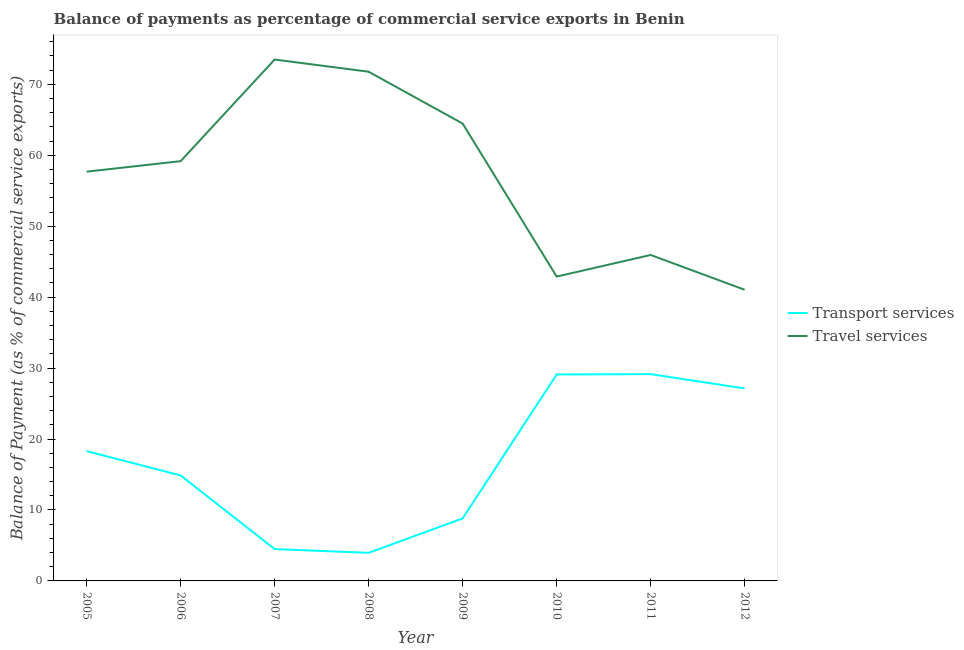What is the balance of payments of transport services in 2007?
Ensure brevity in your answer.  4.49. Across all years, what is the maximum balance of payments of travel services?
Make the answer very short. 73.49. Across all years, what is the minimum balance of payments of transport services?
Provide a short and direct response. 3.96. In which year was the balance of payments of travel services maximum?
Provide a short and direct response. 2007. In which year was the balance of payments of travel services minimum?
Ensure brevity in your answer.  2012. What is the total balance of payments of transport services in the graph?
Offer a very short reply. 135.81. What is the difference between the balance of payments of travel services in 2005 and that in 2011?
Keep it short and to the point. 11.75. What is the difference between the balance of payments of transport services in 2007 and the balance of payments of travel services in 2005?
Offer a very short reply. -53.2. What is the average balance of payments of transport services per year?
Provide a succinct answer. 16.98. In the year 2006, what is the difference between the balance of payments of travel services and balance of payments of transport services?
Keep it short and to the point. 44.29. What is the ratio of the balance of payments of travel services in 2006 to that in 2010?
Provide a short and direct response. 1.38. Is the difference between the balance of payments of travel services in 2007 and 2009 greater than the difference between the balance of payments of transport services in 2007 and 2009?
Provide a succinct answer. Yes. What is the difference between the highest and the second highest balance of payments of transport services?
Provide a short and direct response. 0.05. What is the difference between the highest and the lowest balance of payments of transport services?
Your response must be concise. 25.19. Does the balance of payments of travel services monotonically increase over the years?
Offer a terse response. No. Is the balance of payments of travel services strictly less than the balance of payments of transport services over the years?
Give a very brief answer. No. What is the difference between two consecutive major ticks on the Y-axis?
Keep it short and to the point. 10. Are the values on the major ticks of Y-axis written in scientific E-notation?
Make the answer very short. No. Does the graph contain grids?
Keep it short and to the point. No. How many legend labels are there?
Provide a short and direct response. 2. What is the title of the graph?
Offer a terse response. Balance of payments as percentage of commercial service exports in Benin. What is the label or title of the Y-axis?
Your response must be concise. Balance of Payment (as % of commercial service exports). What is the Balance of Payment (as % of commercial service exports) in Transport services in 2005?
Your answer should be very brief. 18.29. What is the Balance of Payment (as % of commercial service exports) of Travel services in 2005?
Make the answer very short. 57.69. What is the Balance of Payment (as % of commercial service exports) in Transport services in 2006?
Keep it short and to the point. 14.87. What is the Balance of Payment (as % of commercial service exports) in Travel services in 2006?
Keep it short and to the point. 59.17. What is the Balance of Payment (as % of commercial service exports) in Transport services in 2007?
Provide a short and direct response. 4.49. What is the Balance of Payment (as % of commercial service exports) of Travel services in 2007?
Your answer should be very brief. 73.49. What is the Balance of Payment (as % of commercial service exports) of Transport services in 2008?
Your response must be concise. 3.96. What is the Balance of Payment (as % of commercial service exports) of Travel services in 2008?
Offer a terse response. 71.78. What is the Balance of Payment (as % of commercial service exports) of Transport services in 2009?
Provide a succinct answer. 8.81. What is the Balance of Payment (as % of commercial service exports) in Travel services in 2009?
Keep it short and to the point. 64.47. What is the Balance of Payment (as % of commercial service exports) of Transport services in 2010?
Your answer should be compact. 29.1. What is the Balance of Payment (as % of commercial service exports) of Travel services in 2010?
Your answer should be compact. 42.9. What is the Balance of Payment (as % of commercial service exports) of Transport services in 2011?
Offer a very short reply. 29.15. What is the Balance of Payment (as % of commercial service exports) in Travel services in 2011?
Keep it short and to the point. 45.94. What is the Balance of Payment (as % of commercial service exports) of Transport services in 2012?
Your response must be concise. 27.13. What is the Balance of Payment (as % of commercial service exports) of Travel services in 2012?
Offer a very short reply. 41.04. Across all years, what is the maximum Balance of Payment (as % of commercial service exports) of Transport services?
Ensure brevity in your answer.  29.15. Across all years, what is the maximum Balance of Payment (as % of commercial service exports) in Travel services?
Offer a terse response. 73.49. Across all years, what is the minimum Balance of Payment (as % of commercial service exports) of Transport services?
Ensure brevity in your answer.  3.96. Across all years, what is the minimum Balance of Payment (as % of commercial service exports) in Travel services?
Make the answer very short. 41.04. What is the total Balance of Payment (as % of commercial service exports) of Transport services in the graph?
Provide a succinct answer. 135.81. What is the total Balance of Payment (as % of commercial service exports) of Travel services in the graph?
Make the answer very short. 456.48. What is the difference between the Balance of Payment (as % of commercial service exports) of Transport services in 2005 and that in 2006?
Your answer should be compact. 3.42. What is the difference between the Balance of Payment (as % of commercial service exports) in Travel services in 2005 and that in 2006?
Offer a very short reply. -1.48. What is the difference between the Balance of Payment (as % of commercial service exports) in Transport services in 2005 and that in 2007?
Keep it short and to the point. 13.8. What is the difference between the Balance of Payment (as % of commercial service exports) in Travel services in 2005 and that in 2007?
Provide a short and direct response. -15.8. What is the difference between the Balance of Payment (as % of commercial service exports) of Transport services in 2005 and that in 2008?
Your response must be concise. 14.33. What is the difference between the Balance of Payment (as % of commercial service exports) of Travel services in 2005 and that in 2008?
Give a very brief answer. -14.09. What is the difference between the Balance of Payment (as % of commercial service exports) in Transport services in 2005 and that in 2009?
Your response must be concise. 9.48. What is the difference between the Balance of Payment (as % of commercial service exports) of Travel services in 2005 and that in 2009?
Provide a short and direct response. -6.78. What is the difference between the Balance of Payment (as % of commercial service exports) of Transport services in 2005 and that in 2010?
Give a very brief answer. -10.81. What is the difference between the Balance of Payment (as % of commercial service exports) in Travel services in 2005 and that in 2010?
Your answer should be very brief. 14.79. What is the difference between the Balance of Payment (as % of commercial service exports) in Transport services in 2005 and that in 2011?
Provide a succinct answer. -10.86. What is the difference between the Balance of Payment (as % of commercial service exports) of Travel services in 2005 and that in 2011?
Offer a very short reply. 11.74. What is the difference between the Balance of Payment (as % of commercial service exports) of Transport services in 2005 and that in 2012?
Your answer should be very brief. -8.84. What is the difference between the Balance of Payment (as % of commercial service exports) of Travel services in 2005 and that in 2012?
Provide a succinct answer. 16.65. What is the difference between the Balance of Payment (as % of commercial service exports) in Transport services in 2006 and that in 2007?
Give a very brief answer. 10.38. What is the difference between the Balance of Payment (as % of commercial service exports) in Travel services in 2006 and that in 2007?
Provide a succinct answer. -14.33. What is the difference between the Balance of Payment (as % of commercial service exports) of Transport services in 2006 and that in 2008?
Ensure brevity in your answer.  10.91. What is the difference between the Balance of Payment (as % of commercial service exports) of Travel services in 2006 and that in 2008?
Offer a very short reply. -12.61. What is the difference between the Balance of Payment (as % of commercial service exports) in Transport services in 2006 and that in 2009?
Offer a very short reply. 6.06. What is the difference between the Balance of Payment (as % of commercial service exports) in Travel services in 2006 and that in 2009?
Your answer should be compact. -5.3. What is the difference between the Balance of Payment (as % of commercial service exports) in Transport services in 2006 and that in 2010?
Ensure brevity in your answer.  -14.23. What is the difference between the Balance of Payment (as % of commercial service exports) of Travel services in 2006 and that in 2010?
Provide a short and direct response. 16.27. What is the difference between the Balance of Payment (as % of commercial service exports) of Transport services in 2006 and that in 2011?
Provide a succinct answer. -14.28. What is the difference between the Balance of Payment (as % of commercial service exports) of Travel services in 2006 and that in 2011?
Your answer should be very brief. 13.22. What is the difference between the Balance of Payment (as % of commercial service exports) in Transport services in 2006 and that in 2012?
Make the answer very short. -12.26. What is the difference between the Balance of Payment (as % of commercial service exports) of Travel services in 2006 and that in 2012?
Keep it short and to the point. 18.13. What is the difference between the Balance of Payment (as % of commercial service exports) of Transport services in 2007 and that in 2008?
Offer a very short reply. 0.53. What is the difference between the Balance of Payment (as % of commercial service exports) in Travel services in 2007 and that in 2008?
Provide a short and direct response. 1.72. What is the difference between the Balance of Payment (as % of commercial service exports) of Transport services in 2007 and that in 2009?
Give a very brief answer. -4.32. What is the difference between the Balance of Payment (as % of commercial service exports) of Travel services in 2007 and that in 2009?
Your answer should be very brief. 9.03. What is the difference between the Balance of Payment (as % of commercial service exports) in Transport services in 2007 and that in 2010?
Provide a short and direct response. -24.61. What is the difference between the Balance of Payment (as % of commercial service exports) in Travel services in 2007 and that in 2010?
Ensure brevity in your answer.  30.59. What is the difference between the Balance of Payment (as % of commercial service exports) of Transport services in 2007 and that in 2011?
Ensure brevity in your answer.  -24.66. What is the difference between the Balance of Payment (as % of commercial service exports) in Travel services in 2007 and that in 2011?
Offer a terse response. 27.55. What is the difference between the Balance of Payment (as % of commercial service exports) of Transport services in 2007 and that in 2012?
Keep it short and to the point. -22.64. What is the difference between the Balance of Payment (as % of commercial service exports) of Travel services in 2007 and that in 2012?
Provide a succinct answer. 32.45. What is the difference between the Balance of Payment (as % of commercial service exports) in Transport services in 2008 and that in 2009?
Make the answer very short. -4.85. What is the difference between the Balance of Payment (as % of commercial service exports) of Travel services in 2008 and that in 2009?
Provide a short and direct response. 7.31. What is the difference between the Balance of Payment (as % of commercial service exports) of Transport services in 2008 and that in 2010?
Provide a succinct answer. -25.14. What is the difference between the Balance of Payment (as % of commercial service exports) in Travel services in 2008 and that in 2010?
Provide a succinct answer. 28.88. What is the difference between the Balance of Payment (as % of commercial service exports) in Transport services in 2008 and that in 2011?
Ensure brevity in your answer.  -25.19. What is the difference between the Balance of Payment (as % of commercial service exports) in Travel services in 2008 and that in 2011?
Your answer should be compact. 25.83. What is the difference between the Balance of Payment (as % of commercial service exports) of Transport services in 2008 and that in 2012?
Provide a short and direct response. -23.17. What is the difference between the Balance of Payment (as % of commercial service exports) of Travel services in 2008 and that in 2012?
Your answer should be compact. 30.73. What is the difference between the Balance of Payment (as % of commercial service exports) of Transport services in 2009 and that in 2010?
Offer a terse response. -20.29. What is the difference between the Balance of Payment (as % of commercial service exports) of Travel services in 2009 and that in 2010?
Offer a very short reply. 21.57. What is the difference between the Balance of Payment (as % of commercial service exports) in Transport services in 2009 and that in 2011?
Offer a very short reply. -20.34. What is the difference between the Balance of Payment (as % of commercial service exports) of Travel services in 2009 and that in 2011?
Provide a short and direct response. 18.52. What is the difference between the Balance of Payment (as % of commercial service exports) of Transport services in 2009 and that in 2012?
Keep it short and to the point. -18.32. What is the difference between the Balance of Payment (as % of commercial service exports) in Travel services in 2009 and that in 2012?
Your answer should be very brief. 23.42. What is the difference between the Balance of Payment (as % of commercial service exports) of Transport services in 2010 and that in 2011?
Provide a succinct answer. -0.05. What is the difference between the Balance of Payment (as % of commercial service exports) of Travel services in 2010 and that in 2011?
Offer a terse response. -3.04. What is the difference between the Balance of Payment (as % of commercial service exports) of Transport services in 2010 and that in 2012?
Give a very brief answer. 1.97. What is the difference between the Balance of Payment (as % of commercial service exports) in Travel services in 2010 and that in 2012?
Your response must be concise. 1.86. What is the difference between the Balance of Payment (as % of commercial service exports) in Transport services in 2011 and that in 2012?
Ensure brevity in your answer.  2.02. What is the difference between the Balance of Payment (as % of commercial service exports) in Travel services in 2011 and that in 2012?
Your answer should be compact. 4.9. What is the difference between the Balance of Payment (as % of commercial service exports) of Transport services in 2005 and the Balance of Payment (as % of commercial service exports) of Travel services in 2006?
Your answer should be compact. -40.88. What is the difference between the Balance of Payment (as % of commercial service exports) of Transport services in 2005 and the Balance of Payment (as % of commercial service exports) of Travel services in 2007?
Your answer should be compact. -55.2. What is the difference between the Balance of Payment (as % of commercial service exports) in Transport services in 2005 and the Balance of Payment (as % of commercial service exports) in Travel services in 2008?
Give a very brief answer. -53.48. What is the difference between the Balance of Payment (as % of commercial service exports) in Transport services in 2005 and the Balance of Payment (as % of commercial service exports) in Travel services in 2009?
Provide a succinct answer. -46.17. What is the difference between the Balance of Payment (as % of commercial service exports) in Transport services in 2005 and the Balance of Payment (as % of commercial service exports) in Travel services in 2010?
Offer a terse response. -24.61. What is the difference between the Balance of Payment (as % of commercial service exports) of Transport services in 2005 and the Balance of Payment (as % of commercial service exports) of Travel services in 2011?
Provide a succinct answer. -27.65. What is the difference between the Balance of Payment (as % of commercial service exports) of Transport services in 2005 and the Balance of Payment (as % of commercial service exports) of Travel services in 2012?
Your answer should be very brief. -22.75. What is the difference between the Balance of Payment (as % of commercial service exports) in Transport services in 2006 and the Balance of Payment (as % of commercial service exports) in Travel services in 2007?
Provide a succinct answer. -58.62. What is the difference between the Balance of Payment (as % of commercial service exports) in Transport services in 2006 and the Balance of Payment (as % of commercial service exports) in Travel services in 2008?
Provide a succinct answer. -56.9. What is the difference between the Balance of Payment (as % of commercial service exports) of Transport services in 2006 and the Balance of Payment (as % of commercial service exports) of Travel services in 2009?
Your response must be concise. -49.59. What is the difference between the Balance of Payment (as % of commercial service exports) of Transport services in 2006 and the Balance of Payment (as % of commercial service exports) of Travel services in 2010?
Ensure brevity in your answer.  -28.03. What is the difference between the Balance of Payment (as % of commercial service exports) of Transport services in 2006 and the Balance of Payment (as % of commercial service exports) of Travel services in 2011?
Keep it short and to the point. -31.07. What is the difference between the Balance of Payment (as % of commercial service exports) of Transport services in 2006 and the Balance of Payment (as % of commercial service exports) of Travel services in 2012?
Your answer should be very brief. -26.17. What is the difference between the Balance of Payment (as % of commercial service exports) in Transport services in 2007 and the Balance of Payment (as % of commercial service exports) in Travel services in 2008?
Keep it short and to the point. -67.29. What is the difference between the Balance of Payment (as % of commercial service exports) in Transport services in 2007 and the Balance of Payment (as % of commercial service exports) in Travel services in 2009?
Ensure brevity in your answer.  -59.98. What is the difference between the Balance of Payment (as % of commercial service exports) of Transport services in 2007 and the Balance of Payment (as % of commercial service exports) of Travel services in 2010?
Offer a very short reply. -38.41. What is the difference between the Balance of Payment (as % of commercial service exports) in Transport services in 2007 and the Balance of Payment (as % of commercial service exports) in Travel services in 2011?
Ensure brevity in your answer.  -41.46. What is the difference between the Balance of Payment (as % of commercial service exports) of Transport services in 2007 and the Balance of Payment (as % of commercial service exports) of Travel services in 2012?
Ensure brevity in your answer.  -36.55. What is the difference between the Balance of Payment (as % of commercial service exports) of Transport services in 2008 and the Balance of Payment (as % of commercial service exports) of Travel services in 2009?
Offer a very short reply. -60.51. What is the difference between the Balance of Payment (as % of commercial service exports) of Transport services in 2008 and the Balance of Payment (as % of commercial service exports) of Travel services in 2010?
Keep it short and to the point. -38.94. What is the difference between the Balance of Payment (as % of commercial service exports) in Transport services in 2008 and the Balance of Payment (as % of commercial service exports) in Travel services in 2011?
Provide a succinct answer. -41.99. What is the difference between the Balance of Payment (as % of commercial service exports) of Transport services in 2008 and the Balance of Payment (as % of commercial service exports) of Travel services in 2012?
Provide a short and direct response. -37.08. What is the difference between the Balance of Payment (as % of commercial service exports) of Transport services in 2009 and the Balance of Payment (as % of commercial service exports) of Travel services in 2010?
Give a very brief answer. -34.09. What is the difference between the Balance of Payment (as % of commercial service exports) of Transport services in 2009 and the Balance of Payment (as % of commercial service exports) of Travel services in 2011?
Your answer should be very brief. -37.13. What is the difference between the Balance of Payment (as % of commercial service exports) of Transport services in 2009 and the Balance of Payment (as % of commercial service exports) of Travel services in 2012?
Offer a terse response. -32.23. What is the difference between the Balance of Payment (as % of commercial service exports) in Transport services in 2010 and the Balance of Payment (as % of commercial service exports) in Travel services in 2011?
Ensure brevity in your answer.  -16.84. What is the difference between the Balance of Payment (as % of commercial service exports) in Transport services in 2010 and the Balance of Payment (as % of commercial service exports) in Travel services in 2012?
Your answer should be compact. -11.94. What is the difference between the Balance of Payment (as % of commercial service exports) of Transport services in 2011 and the Balance of Payment (as % of commercial service exports) of Travel services in 2012?
Your response must be concise. -11.89. What is the average Balance of Payment (as % of commercial service exports) in Transport services per year?
Your response must be concise. 16.98. What is the average Balance of Payment (as % of commercial service exports) of Travel services per year?
Make the answer very short. 57.06. In the year 2005, what is the difference between the Balance of Payment (as % of commercial service exports) in Transport services and Balance of Payment (as % of commercial service exports) in Travel services?
Your answer should be very brief. -39.4. In the year 2006, what is the difference between the Balance of Payment (as % of commercial service exports) of Transport services and Balance of Payment (as % of commercial service exports) of Travel services?
Provide a succinct answer. -44.29. In the year 2007, what is the difference between the Balance of Payment (as % of commercial service exports) in Transport services and Balance of Payment (as % of commercial service exports) in Travel services?
Your answer should be very brief. -69.01. In the year 2008, what is the difference between the Balance of Payment (as % of commercial service exports) of Transport services and Balance of Payment (as % of commercial service exports) of Travel services?
Your answer should be very brief. -67.82. In the year 2009, what is the difference between the Balance of Payment (as % of commercial service exports) in Transport services and Balance of Payment (as % of commercial service exports) in Travel services?
Your answer should be very brief. -55.66. In the year 2010, what is the difference between the Balance of Payment (as % of commercial service exports) of Transport services and Balance of Payment (as % of commercial service exports) of Travel services?
Provide a short and direct response. -13.8. In the year 2011, what is the difference between the Balance of Payment (as % of commercial service exports) in Transport services and Balance of Payment (as % of commercial service exports) in Travel services?
Give a very brief answer. -16.79. In the year 2012, what is the difference between the Balance of Payment (as % of commercial service exports) in Transport services and Balance of Payment (as % of commercial service exports) in Travel services?
Keep it short and to the point. -13.91. What is the ratio of the Balance of Payment (as % of commercial service exports) of Transport services in 2005 to that in 2006?
Offer a very short reply. 1.23. What is the ratio of the Balance of Payment (as % of commercial service exports) in Travel services in 2005 to that in 2006?
Provide a short and direct response. 0.97. What is the ratio of the Balance of Payment (as % of commercial service exports) of Transport services in 2005 to that in 2007?
Give a very brief answer. 4.07. What is the ratio of the Balance of Payment (as % of commercial service exports) of Travel services in 2005 to that in 2007?
Provide a short and direct response. 0.79. What is the ratio of the Balance of Payment (as % of commercial service exports) in Transport services in 2005 to that in 2008?
Your answer should be compact. 4.62. What is the ratio of the Balance of Payment (as % of commercial service exports) of Travel services in 2005 to that in 2008?
Your response must be concise. 0.8. What is the ratio of the Balance of Payment (as % of commercial service exports) of Transport services in 2005 to that in 2009?
Give a very brief answer. 2.08. What is the ratio of the Balance of Payment (as % of commercial service exports) of Travel services in 2005 to that in 2009?
Ensure brevity in your answer.  0.89. What is the ratio of the Balance of Payment (as % of commercial service exports) in Transport services in 2005 to that in 2010?
Your answer should be very brief. 0.63. What is the ratio of the Balance of Payment (as % of commercial service exports) of Travel services in 2005 to that in 2010?
Your response must be concise. 1.34. What is the ratio of the Balance of Payment (as % of commercial service exports) of Transport services in 2005 to that in 2011?
Your response must be concise. 0.63. What is the ratio of the Balance of Payment (as % of commercial service exports) of Travel services in 2005 to that in 2011?
Provide a short and direct response. 1.26. What is the ratio of the Balance of Payment (as % of commercial service exports) in Transport services in 2005 to that in 2012?
Keep it short and to the point. 0.67. What is the ratio of the Balance of Payment (as % of commercial service exports) of Travel services in 2005 to that in 2012?
Your response must be concise. 1.41. What is the ratio of the Balance of Payment (as % of commercial service exports) in Transport services in 2006 to that in 2007?
Keep it short and to the point. 3.31. What is the ratio of the Balance of Payment (as % of commercial service exports) of Travel services in 2006 to that in 2007?
Give a very brief answer. 0.81. What is the ratio of the Balance of Payment (as % of commercial service exports) in Transport services in 2006 to that in 2008?
Your answer should be very brief. 3.76. What is the ratio of the Balance of Payment (as % of commercial service exports) in Travel services in 2006 to that in 2008?
Provide a succinct answer. 0.82. What is the ratio of the Balance of Payment (as % of commercial service exports) in Transport services in 2006 to that in 2009?
Your response must be concise. 1.69. What is the ratio of the Balance of Payment (as % of commercial service exports) in Travel services in 2006 to that in 2009?
Your response must be concise. 0.92. What is the ratio of the Balance of Payment (as % of commercial service exports) in Transport services in 2006 to that in 2010?
Offer a very short reply. 0.51. What is the ratio of the Balance of Payment (as % of commercial service exports) in Travel services in 2006 to that in 2010?
Keep it short and to the point. 1.38. What is the ratio of the Balance of Payment (as % of commercial service exports) in Transport services in 2006 to that in 2011?
Keep it short and to the point. 0.51. What is the ratio of the Balance of Payment (as % of commercial service exports) of Travel services in 2006 to that in 2011?
Give a very brief answer. 1.29. What is the ratio of the Balance of Payment (as % of commercial service exports) in Transport services in 2006 to that in 2012?
Give a very brief answer. 0.55. What is the ratio of the Balance of Payment (as % of commercial service exports) of Travel services in 2006 to that in 2012?
Offer a terse response. 1.44. What is the ratio of the Balance of Payment (as % of commercial service exports) in Transport services in 2007 to that in 2008?
Make the answer very short. 1.13. What is the ratio of the Balance of Payment (as % of commercial service exports) of Travel services in 2007 to that in 2008?
Your answer should be very brief. 1.02. What is the ratio of the Balance of Payment (as % of commercial service exports) in Transport services in 2007 to that in 2009?
Your response must be concise. 0.51. What is the ratio of the Balance of Payment (as % of commercial service exports) in Travel services in 2007 to that in 2009?
Offer a terse response. 1.14. What is the ratio of the Balance of Payment (as % of commercial service exports) of Transport services in 2007 to that in 2010?
Your answer should be compact. 0.15. What is the ratio of the Balance of Payment (as % of commercial service exports) of Travel services in 2007 to that in 2010?
Your answer should be very brief. 1.71. What is the ratio of the Balance of Payment (as % of commercial service exports) of Transport services in 2007 to that in 2011?
Keep it short and to the point. 0.15. What is the ratio of the Balance of Payment (as % of commercial service exports) of Travel services in 2007 to that in 2011?
Offer a very short reply. 1.6. What is the ratio of the Balance of Payment (as % of commercial service exports) of Transport services in 2007 to that in 2012?
Make the answer very short. 0.17. What is the ratio of the Balance of Payment (as % of commercial service exports) of Travel services in 2007 to that in 2012?
Provide a succinct answer. 1.79. What is the ratio of the Balance of Payment (as % of commercial service exports) in Transport services in 2008 to that in 2009?
Your response must be concise. 0.45. What is the ratio of the Balance of Payment (as % of commercial service exports) in Travel services in 2008 to that in 2009?
Offer a very short reply. 1.11. What is the ratio of the Balance of Payment (as % of commercial service exports) in Transport services in 2008 to that in 2010?
Make the answer very short. 0.14. What is the ratio of the Balance of Payment (as % of commercial service exports) in Travel services in 2008 to that in 2010?
Give a very brief answer. 1.67. What is the ratio of the Balance of Payment (as % of commercial service exports) of Transport services in 2008 to that in 2011?
Your response must be concise. 0.14. What is the ratio of the Balance of Payment (as % of commercial service exports) of Travel services in 2008 to that in 2011?
Provide a short and direct response. 1.56. What is the ratio of the Balance of Payment (as % of commercial service exports) in Transport services in 2008 to that in 2012?
Your answer should be very brief. 0.15. What is the ratio of the Balance of Payment (as % of commercial service exports) of Travel services in 2008 to that in 2012?
Your response must be concise. 1.75. What is the ratio of the Balance of Payment (as % of commercial service exports) of Transport services in 2009 to that in 2010?
Your response must be concise. 0.3. What is the ratio of the Balance of Payment (as % of commercial service exports) in Travel services in 2009 to that in 2010?
Your answer should be compact. 1.5. What is the ratio of the Balance of Payment (as % of commercial service exports) in Transport services in 2009 to that in 2011?
Keep it short and to the point. 0.3. What is the ratio of the Balance of Payment (as % of commercial service exports) of Travel services in 2009 to that in 2011?
Offer a terse response. 1.4. What is the ratio of the Balance of Payment (as % of commercial service exports) of Transport services in 2009 to that in 2012?
Give a very brief answer. 0.32. What is the ratio of the Balance of Payment (as % of commercial service exports) of Travel services in 2009 to that in 2012?
Make the answer very short. 1.57. What is the ratio of the Balance of Payment (as % of commercial service exports) of Transport services in 2010 to that in 2011?
Give a very brief answer. 1. What is the ratio of the Balance of Payment (as % of commercial service exports) of Travel services in 2010 to that in 2011?
Provide a succinct answer. 0.93. What is the ratio of the Balance of Payment (as % of commercial service exports) of Transport services in 2010 to that in 2012?
Provide a short and direct response. 1.07. What is the ratio of the Balance of Payment (as % of commercial service exports) in Travel services in 2010 to that in 2012?
Make the answer very short. 1.05. What is the ratio of the Balance of Payment (as % of commercial service exports) of Transport services in 2011 to that in 2012?
Provide a short and direct response. 1.07. What is the ratio of the Balance of Payment (as % of commercial service exports) of Travel services in 2011 to that in 2012?
Provide a short and direct response. 1.12. What is the difference between the highest and the second highest Balance of Payment (as % of commercial service exports) in Transport services?
Make the answer very short. 0.05. What is the difference between the highest and the second highest Balance of Payment (as % of commercial service exports) in Travel services?
Offer a very short reply. 1.72. What is the difference between the highest and the lowest Balance of Payment (as % of commercial service exports) in Transport services?
Keep it short and to the point. 25.19. What is the difference between the highest and the lowest Balance of Payment (as % of commercial service exports) in Travel services?
Offer a very short reply. 32.45. 